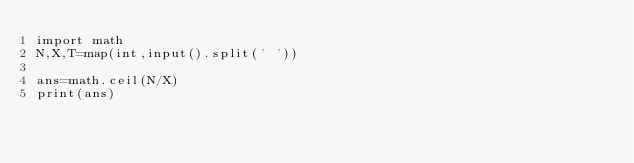<code> <loc_0><loc_0><loc_500><loc_500><_Python_>import math
N,X,T=map(int,input().split(' '))
 
ans=math.ceil(N/X)
print(ans)</code> 